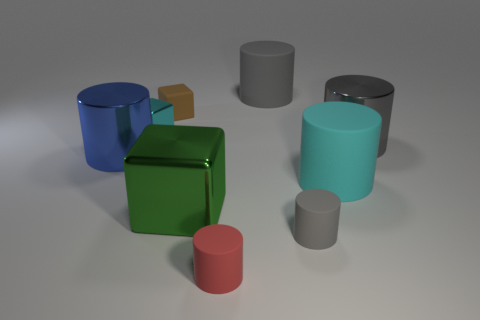Subtract all gray cylinders. How many were subtracted if there are1gray cylinders left? 2 Subtract all rubber cubes. How many cubes are left? 2 Subtract all cyan cylinders. How many cylinders are left? 5 Subtract all blocks. How many objects are left? 6 Subtract all green blocks. How many gray cylinders are left? 3 Subtract 1 cubes. How many cubes are left? 2 Subtract all blue cylinders. Subtract all tiny brown cubes. How many objects are left? 7 Add 9 red cylinders. How many red cylinders are left? 10 Add 2 large gray shiny things. How many large gray shiny things exist? 3 Subtract 0 red spheres. How many objects are left? 9 